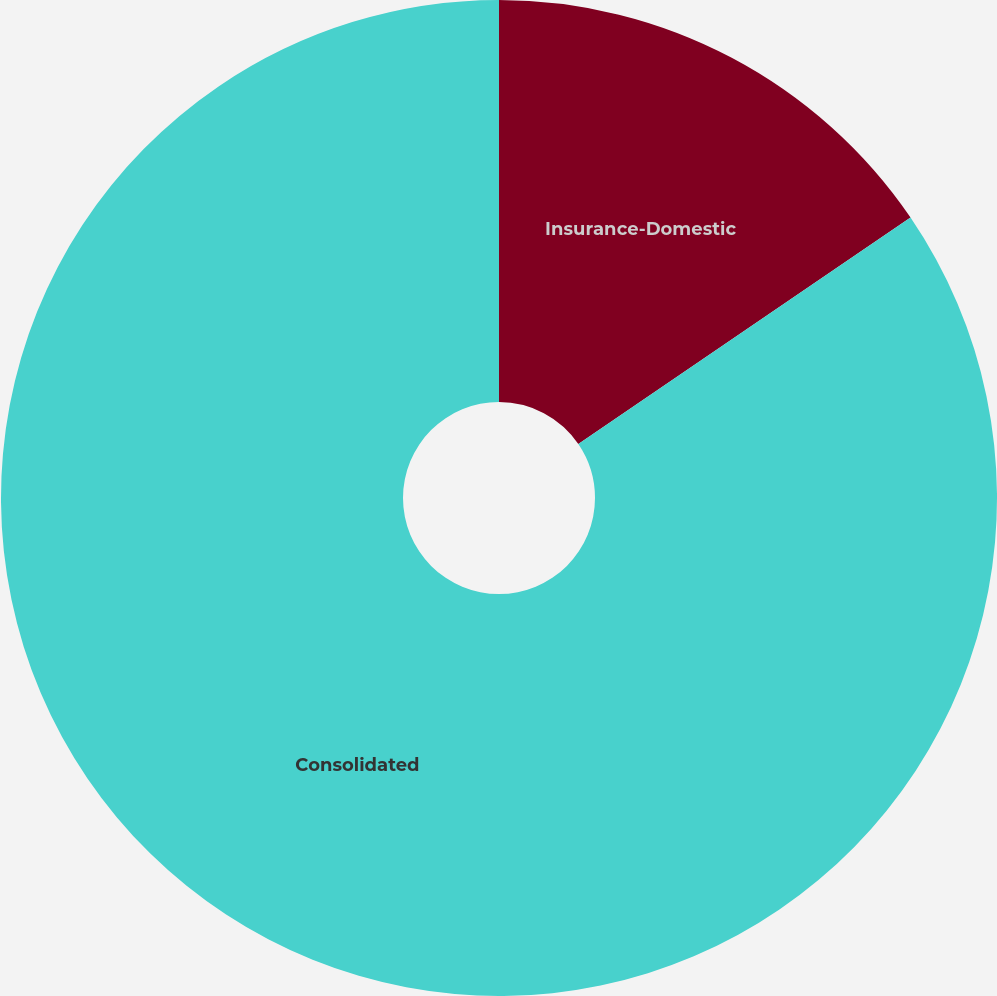Convert chart. <chart><loc_0><loc_0><loc_500><loc_500><pie_chart><fcel>Insurance-Domestic<fcel>Consolidated<nl><fcel>15.48%<fcel>84.52%<nl></chart> 